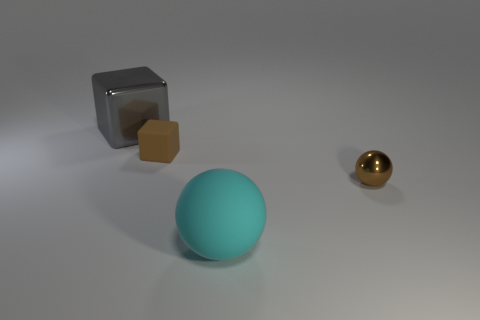How many other things are the same size as the gray thing?
Provide a succinct answer. 1. There is a thing that is to the right of the big cube and behind the small brown metal object; what shape is it?
Make the answer very short. Cube. Are there an equal number of big rubber spheres to the right of the large cyan sphere and big objects that are right of the gray object?
Your answer should be very brief. No. What number of cylinders are cyan matte objects or gray metallic things?
Provide a succinct answer. 0. What number of other blocks are the same material as the large gray cube?
Provide a succinct answer. 0. There is a tiny matte thing that is the same color as the tiny sphere; what is its shape?
Your response must be concise. Cube. There is a thing that is both in front of the large metal object and left of the big cyan matte thing; what is its material?
Your answer should be very brief. Rubber. What is the shape of the brown thing that is to the left of the brown metal ball?
Give a very brief answer. Cube. What is the shape of the big object that is in front of the thing to the left of the brown rubber thing?
Your answer should be compact. Sphere. Are there any tiny yellow things that have the same shape as the gray thing?
Your response must be concise. No. 